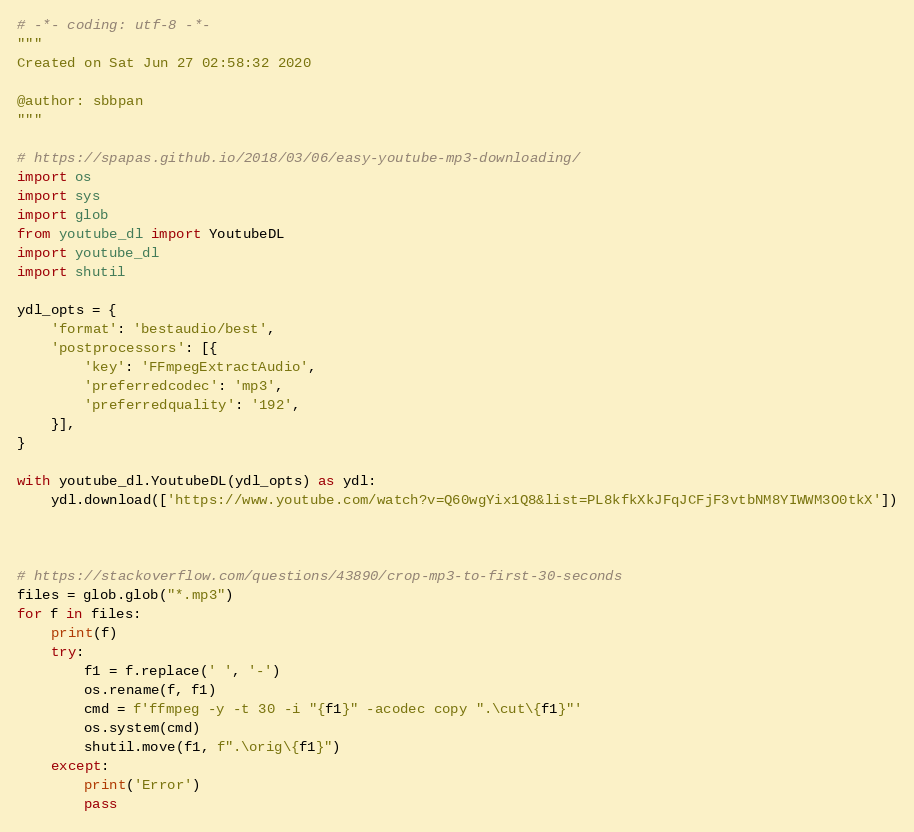Convert code to text. <code><loc_0><loc_0><loc_500><loc_500><_Python_># -*- coding: utf-8 -*-
"""
Created on Sat Jun 27 02:58:32 2020

@author: sbbpan
"""

# https://spapas.github.io/2018/03/06/easy-youtube-mp3-downloading/
import os
import sys
import glob
from youtube_dl import YoutubeDL
import youtube_dl
import shutil

ydl_opts = {
    'format': 'bestaudio/best',
    'postprocessors': [{
        'key': 'FFmpegExtractAudio',
        'preferredcodec': 'mp3',
        'preferredquality': '192',
    }],
}
    
with youtube_dl.YoutubeDL(ydl_opts) as ydl:
    ydl.download(['https://www.youtube.com/watch?v=Q60wgYix1Q8&list=PL8kfkXkJFqJCFjF3vtbNM8YIWWM3O0tkX'])
    
    

# https://stackoverflow.com/questions/43890/crop-mp3-to-first-30-seconds
files = glob.glob("*.mp3")
for f in files:
    print(f)
    try:
        f1 = f.replace(' ', '-')    
        os.rename(f, f1)    
        cmd = f'ffmpeg -y -t 30 -i "{f1}" -acodec copy ".\cut\{f1}"'
        os.system(cmd)    
        shutil.move(f1, f".\orig\{f1}")
    except:
        print('Error')
        pass</code> 